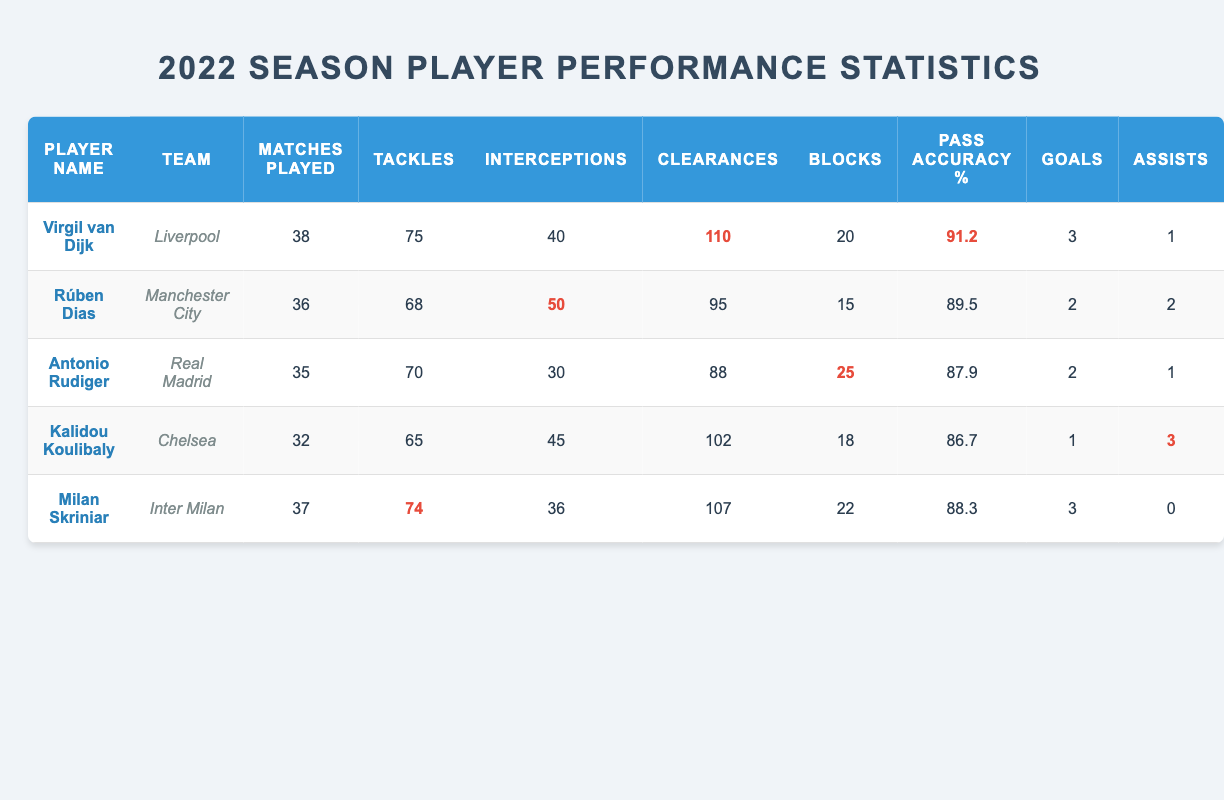What is the total number of tackles made by all players in the table? To find the total number of tackles, we add the tackles for each player: 75 (van Dijk) + 68 (Dias) + 70 (Rudiger) + 65 (Koulibaly) + 74 (Skriniar) = 352
Answer: 352 Which player has the highest pass accuracy percentage? By comparing the pass accuracy percentages from the table, Virgil van Dijk has the highest percentage at 91.2.
Answer: Virgil van Dijk How many assists did Milan Skriniar have? According to the table, Milan Skriniar has 0 assists listed.
Answer: 0 Did any player score more than three goals in the 2022 season? Reviewing the goals scored by each player, the maximum is three goals (scored by van Dijk and Skriniar), so no player scored more than three goals.
Answer: No What is the average number of clearances made by players in this season? To calculate the average clearances: (110 + 95 + 88 + 102 + 107) = 502. Divide by 5 players (502 / 5) = 100.4
Answer: 100.4 Which team had the player with the most clearances? Looking at the clearances, Virgil van Dijk from Liverpool has the most with 110 clearances.
Answer: Liverpool Was the number of interceptions made by Rúben Dias higher than that of Kalidou Koulibaly? Comparing the interceptions, Rúben Dias had 50 while Kalidou Koulibaly had 45. 50 is greater than 45, meaning Dias had more interceptions.
Answer: Yes How many players played more than 35 matches? Checking the matches played, van Dijk (38), Dias (36), and Skriniar (37) played more than 35 matches. Thus, there are three players.
Answer: 3 Which player had the fewest goals scored? The table shows that Kalidou Koulibaly scored the fewest goals, with just one goal.
Answer: Kalidou Koulibaly 